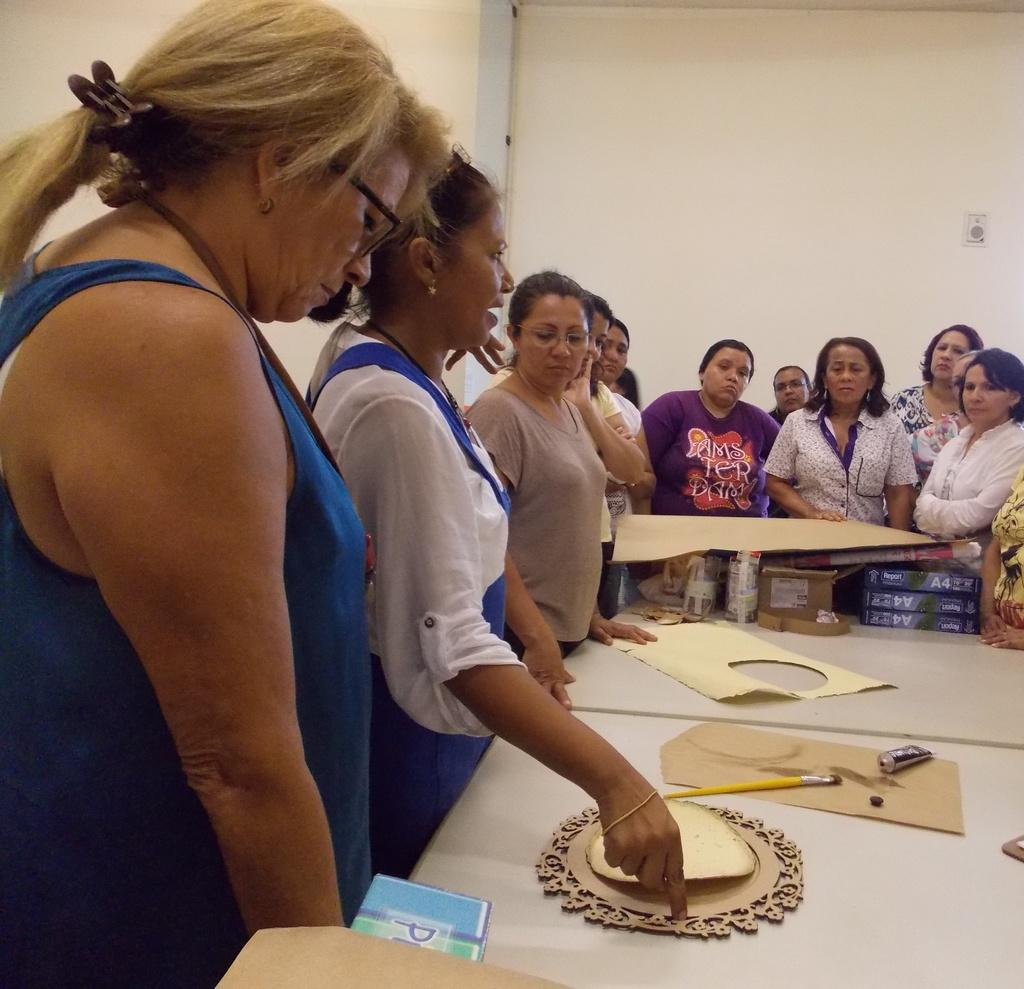What is the main subject of the image? The main subject of the image is a group of women. What are the women doing in the image? The women are standing around a table. What items can be seen on the table? There is paper, cardboard, glue, and a brush on the table. What type of stew is being prepared on the table in the image? There is no stew present in the image; the table contains paper, cardboard, glue, and a brush. What type of society is depicted in the image? The image does not depict a society; it shows a group of women standing around a table with various items. 